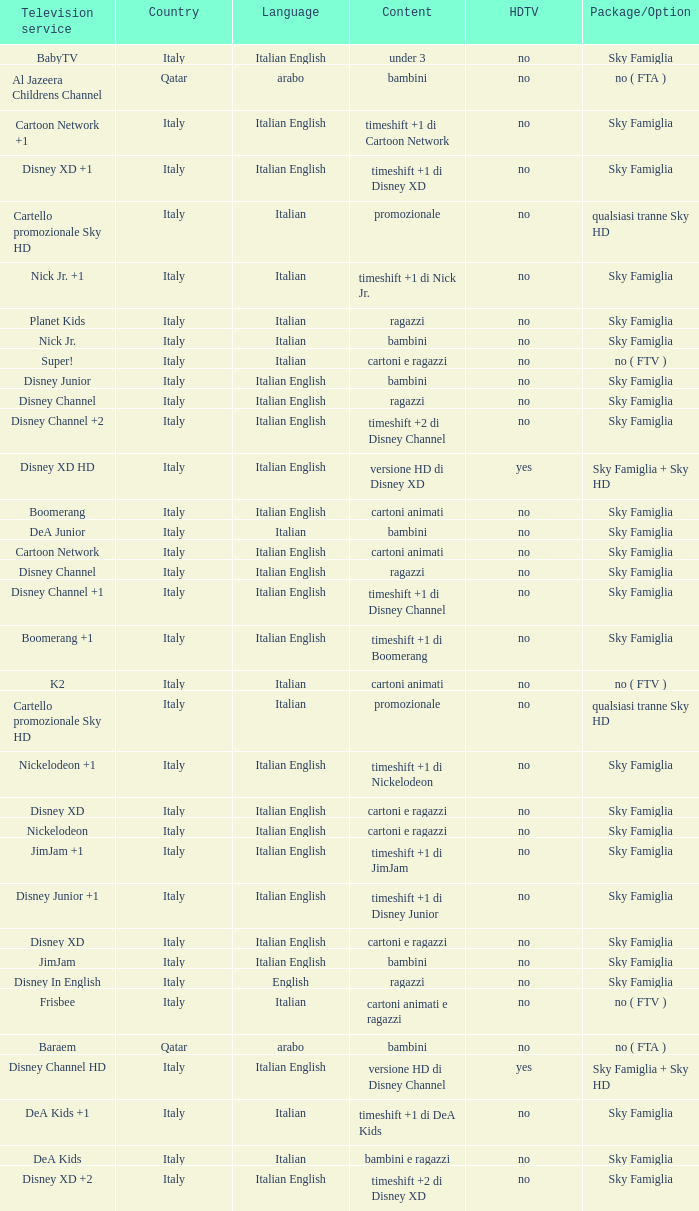What is the HDTV when the Package/Option is sky famiglia, and a Television service of boomerang +1? No. 